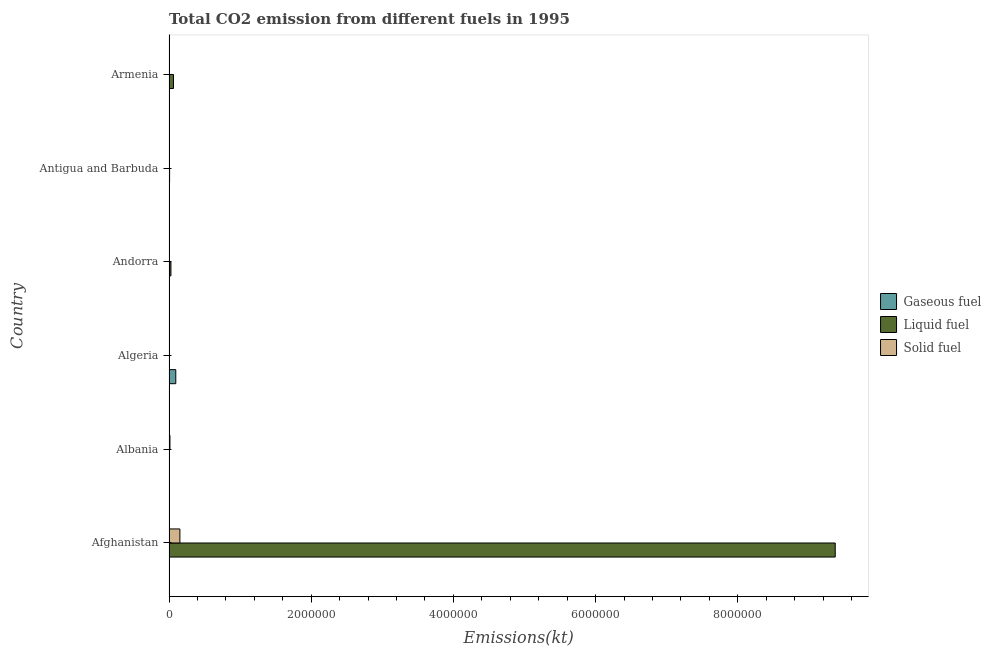How many different coloured bars are there?
Offer a very short reply. 3. How many groups of bars are there?
Ensure brevity in your answer.  6. Are the number of bars on each tick of the Y-axis equal?
Your response must be concise. Yes. How many bars are there on the 5th tick from the top?
Offer a very short reply. 3. How many bars are there on the 6th tick from the bottom?
Make the answer very short. 3. What is the label of the 3rd group of bars from the top?
Offer a terse response. Andorra. What is the amount of co2 emissions from solid fuel in Antigua and Barbuda?
Your answer should be very brief. 1221.11. Across all countries, what is the maximum amount of co2 emissions from liquid fuel?
Keep it short and to the point. 9.37e+06. Across all countries, what is the minimum amount of co2 emissions from solid fuel?
Keep it short and to the point. 3.67. In which country was the amount of co2 emissions from gaseous fuel maximum?
Make the answer very short. Algeria. In which country was the amount of co2 emissions from liquid fuel minimum?
Ensure brevity in your answer.  Albania. What is the total amount of co2 emissions from solid fuel in the graph?
Give a very brief answer. 1.73e+05. What is the difference between the amount of co2 emissions from liquid fuel in Andorra and that in Armenia?
Ensure brevity in your answer.  -3.58e+04. What is the difference between the amount of co2 emissions from gaseous fuel in Andorra and the amount of co2 emissions from solid fuel in Algeria?
Offer a very short reply. 392.37. What is the average amount of co2 emissions from gaseous fuel per country?
Make the answer very short. 1.72e+04. What is the difference between the amount of co2 emissions from gaseous fuel and amount of co2 emissions from solid fuel in Algeria?
Ensure brevity in your answer.  9.53e+04. In how many countries, is the amount of co2 emissions from solid fuel greater than 1600000 kt?
Provide a short and direct response. 0. What is the ratio of the amount of co2 emissions from solid fuel in Andorra to that in Armenia?
Offer a very short reply. 0. Is the amount of co2 emissions from liquid fuel in Afghanistan less than that in Algeria?
Offer a very short reply. No. What is the difference between the highest and the second highest amount of co2 emissions from solid fuel?
Ensure brevity in your answer.  1.40e+05. What is the difference between the highest and the lowest amount of co2 emissions from liquid fuel?
Offer a very short reply. 9.37e+06. What does the 3rd bar from the top in Algeria represents?
Offer a very short reply. Gaseous fuel. What does the 1st bar from the bottom in Armenia represents?
Make the answer very short. Gaseous fuel. Is it the case that in every country, the sum of the amount of co2 emissions from gaseous fuel and amount of co2 emissions from liquid fuel is greater than the amount of co2 emissions from solid fuel?
Provide a succinct answer. No. How many bars are there?
Offer a terse response. 18. Are all the bars in the graph horizontal?
Your answer should be compact. Yes. Are the values on the major ticks of X-axis written in scientific E-notation?
Make the answer very short. No. Does the graph contain any zero values?
Offer a very short reply. No. Does the graph contain grids?
Offer a very short reply. No. How many legend labels are there?
Provide a succinct answer. 3. What is the title of the graph?
Ensure brevity in your answer.  Total CO2 emission from different fuels in 1995. What is the label or title of the X-axis?
Provide a short and direct response. Emissions(kt). What is the Emissions(kt) in Gaseous fuel in Afghanistan?
Your answer should be very brief. 1268.78. What is the Emissions(kt) in Liquid fuel in Afghanistan?
Your answer should be compact. 9.37e+06. What is the Emissions(kt) in Solid fuel in Afghanistan?
Your response must be concise. 1.53e+05. What is the Emissions(kt) of Gaseous fuel in Albania?
Provide a succinct answer. 2086.52. What is the Emissions(kt) of Liquid fuel in Albania?
Your answer should be compact. 850.74. What is the Emissions(kt) in Solid fuel in Albania?
Offer a terse response. 1.32e+04. What is the Emissions(kt) in Gaseous fuel in Algeria?
Offer a very short reply. 9.53e+04. What is the Emissions(kt) in Liquid fuel in Algeria?
Your answer should be very brief. 1774.83. What is the Emissions(kt) in Solid fuel in Algeria?
Your answer should be compact. 14.67. What is the Emissions(kt) of Gaseous fuel in Andorra?
Your answer should be compact. 407.04. What is the Emissions(kt) of Liquid fuel in Andorra?
Provide a short and direct response. 2.71e+04. What is the Emissions(kt) in Solid fuel in Andorra?
Your answer should be very brief. 3.67. What is the Emissions(kt) of Gaseous fuel in Antigua and Barbuda?
Keep it short and to the point. 322.7. What is the Emissions(kt) of Liquid fuel in Antigua and Barbuda?
Make the answer very short. 8459.77. What is the Emissions(kt) in Solid fuel in Antigua and Barbuda?
Your response must be concise. 1221.11. What is the Emissions(kt) of Gaseous fuel in Armenia?
Ensure brevity in your answer.  3490.98. What is the Emissions(kt) of Liquid fuel in Armenia?
Give a very brief answer. 6.29e+04. What is the Emissions(kt) of Solid fuel in Armenia?
Keep it short and to the point. 5291.48. Across all countries, what is the maximum Emissions(kt) in Gaseous fuel?
Your answer should be very brief. 9.53e+04. Across all countries, what is the maximum Emissions(kt) of Liquid fuel?
Your answer should be very brief. 9.37e+06. Across all countries, what is the maximum Emissions(kt) of Solid fuel?
Keep it short and to the point. 1.53e+05. Across all countries, what is the minimum Emissions(kt) of Gaseous fuel?
Give a very brief answer. 322.7. Across all countries, what is the minimum Emissions(kt) in Liquid fuel?
Provide a succinct answer. 850.74. Across all countries, what is the minimum Emissions(kt) of Solid fuel?
Your response must be concise. 3.67. What is the total Emissions(kt) in Gaseous fuel in the graph?
Keep it short and to the point. 1.03e+05. What is the total Emissions(kt) in Liquid fuel in the graph?
Keep it short and to the point. 9.47e+06. What is the total Emissions(kt) of Solid fuel in the graph?
Make the answer very short. 1.73e+05. What is the difference between the Emissions(kt) in Gaseous fuel in Afghanistan and that in Albania?
Offer a terse response. -817.74. What is the difference between the Emissions(kt) in Liquid fuel in Afghanistan and that in Albania?
Provide a succinct answer. 9.37e+06. What is the difference between the Emissions(kt) of Solid fuel in Afghanistan and that in Albania?
Offer a very short reply. 1.40e+05. What is the difference between the Emissions(kt) of Gaseous fuel in Afghanistan and that in Algeria?
Ensure brevity in your answer.  -9.41e+04. What is the difference between the Emissions(kt) in Liquid fuel in Afghanistan and that in Algeria?
Give a very brief answer. 9.37e+06. What is the difference between the Emissions(kt) of Solid fuel in Afghanistan and that in Algeria?
Your answer should be compact. 1.53e+05. What is the difference between the Emissions(kt) of Gaseous fuel in Afghanistan and that in Andorra?
Provide a succinct answer. 861.75. What is the difference between the Emissions(kt) of Liquid fuel in Afghanistan and that in Andorra?
Make the answer very short. 9.34e+06. What is the difference between the Emissions(kt) in Solid fuel in Afghanistan and that in Andorra?
Give a very brief answer. 1.53e+05. What is the difference between the Emissions(kt) in Gaseous fuel in Afghanistan and that in Antigua and Barbuda?
Give a very brief answer. 946.09. What is the difference between the Emissions(kt) in Liquid fuel in Afghanistan and that in Antigua and Barbuda?
Your answer should be very brief. 9.36e+06. What is the difference between the Emissions(kt) in Solid fuel in Afghanistan and that in Antigua and Barbuda?
Keep it short and to the point. 1.52e+05. What is the difference between the Emissions(kt) of Gaseous fuel in Afghanistan and that in Armenia?
Offer a very short reply. -2222.2. What is the difference between the Emissions(kt) in Liquid fuel in Afghanistan and that in Armenia?
Keep it short and to the point. 9.31e+06. What is the difference between the Emissions(kt) of Solid fuel in Afghanistan and that in Armenia?
Keep it short and to the point. 1.48e+05. What is the difference between the Emissions(kt) of Gaseous fuel in Albania and that in Algeria?
Your answer should be very brief. -9.33e+04. What is the difference between the Emissions(kt) in Liquid fuel in Albania and that in Algeria?
Provide a short and direct response. -924.08. What is the difference between the Emissions(kt) in Solid fuel in Albania and that in Algeria?
Ensure brevity in your answer.  1.32e+04. What is the difference between the Emissions(kt) of Gaseous fuel in Albania and that in Andorra?
Your answer should be compact. 1679.49. What is the difference between the Emissions(kt) of Liquid fuel in Albania and that in Andorra?
Offer a terse response. -2.63e+04. What is the difference between the Emissions(kt) of Solid fuel in Albania and that in Andorra?
Your response must be concise. 1.32e+04. What is the difference between the Emissions(kt) in Gaseous fuel in Albania and that in Antigua and Barbuda?
Give a very brief answer. 1763.83. What is the difference between the Emissions(kt) of Liquid fuel in Albania and that in Antigua and Barbuda?
Your answer should be compact. -7609.02. What is the difference between the Emissions(kt) in Solid fuel in Albania and that in Antigua and Barbuda?
Your answer should be very brief. 1.20e+04. What is the difference between the Emissions(kt) in Gaseous fuel in Albania and that in Armenia?
Your response must be concise. -1404.46. What is the difference between the Emissions(kt) of Liquid fuel in Albania and that in Armenia?
Provide a short and direct response. -6.20e+04. What is the difference between the Emissions(kt) of Solid fuel in Albania and that in Armenia?
Your answer should be very brief. 7924.39. What is the difference between the Emissions(kt) of Gaseous fuel in Algeria and that in Andorra?
Your response must be concise. 9.49e+04. What is the difference between the Emissions(kt) in Liquid fuel in Algeria and that in Andorra?
Your response must be concise. -2.53e+04. What is the difference between the Emissions(kt) in Solid fuel in Algeria and that in Andorra?
Provide a short and direct response. 11. What is the difference between the Emissions(kt) of Gaseous fuel in Algeria and that in Antigua and Barbuda?
Offer a terse response. 9.50e+04. What is the difference between the Emissions(kt) in Liquid fuel in Algeria and that in Antigua and Barbuda?
Give a very brief answer. -6684.94. What is the difference between the Emissions(kt) of Solid fuel in Algeria and that in Antigua and Barbuda?
Your response must be concise. -1206.44. What is the difference between the Emissions(kt) of Gaseous fuel in Algeria and that in Armenia?
Offer a very short reply. 9.19e+04. What is the difference between the Emissions(kt) in Liquid fuel in Algeria and that in Armenia?
Ensure brevity in your answer.  -6.11e+04. What is the difference between the Emissions(kt) of Solid fuel in Algeria and that in Armenia?
Provide a succinct answer. -5276.81. What is the difference between the Emissions(kt) in Gaseous fuel in Andorra and that in Antigua and Barbuda?
Give a very brief answer. 84.34. What is the difference between the Emissions(kt) in Liquid fuel in Andorra and that in Antigua and Barbuda?
Provide a short and direct response. 1.86e+04. What is the difference between the Emissions(kt) of Solid fuel in Andorra and that in Antigua and Barbuda?
Provide a succinct answer. -1217.44. What is the difference between the Emissions(kt) of Gaseous fuel in Andorra and that in Armenia?
Provide a succinct answer. -3083.95. What is the difference between the Emissions(kt) of Liquid fuel in Andorra and that in Armenia?
Offer a very short reply. -3.58e+04. What is the difference between the Emissions(kt) in Solid fuel in Andorra and that in Armenia?
Give a very brief answer. -5287.81. What is the difference between the Emissions(kt) in Gaseous fuel in Antigua and Barbuda and that in Armenia?
Make the answer very short. -3168.29. What is the difference between the Emissions(kt) in Liquid fuel in Antigua and Barbuda and that in Armenia?
Offer a very short reply. -5.44e+04. What is the difference between the Emissions(kt) of Solid fuel in Antigua and Barbuda and that in Armenia?
Provide a succinct answer. -4070.37. What is the difference between the Emissions(kt) in Gaseous fuel in Afghanistan and the Emissions(kt) in Liquid fuel in Albania?
Offer a terse response. 418.04. What is the difference between the Emissions(kt) of Gaseous fuel in Afghanistan and the Emissions(kt) of Solid fuel in Albania?
Your answer should be very brief. -1.19e+04. What is the difference between the Emissions(kt) in Liquid fuel in Afghanistan and the Emissions(kt) in Solid fuel in Albania?
Provide a succinct answer. 9.36e+06. What is the difference between the Emissions(kt) of Gaseous fuel in Afghanistan and the Emissions(kt) of Liquid fuel in Algeria?
Offer a terse response. -506.05. What is the difference between the Emissions(kt) in Gaseous fuel in Afghanistan and the Emissions(kt) in Solid fuel in Algeria?
Provide a short and direct response. 1254.11. What is the difference between the Emissions(kt) in Liquid fuel in Afghanistan and the Emissions(kt) in Solid fuel in Algeria?
Your response must be concise. 9.37e+06. What is the difference between the Emissions(kt) of Gaseous fuel in Afghanistan and the Emissions(kt) of Liquid fuel in Andorra?
Offer a terse response. -2.58e+04. What is the difference between the Emissions(kt) of Gaseous fuel in Afghanistan and the Emissions(kt) of Solid fuel in Andorra?
Ensure brevity in your answer.  1265.12. What is the difference between the Emissions(kt) of Liquid fuel in Afghanistan and the Emissions(kt) of Solid fuel in Andorra?
Your answer should be compact. 9.37e+06. What is the difference between the Emissions(kt) in Gaseous fuel in Afghanistan and the Emissions(kt) in Liquid fuel in Antigua and Barbuda?
Provide a short and direct response. -7190.99. What is the difference between the Emissions(kt) of Gaseous fuel in Afghanistan and the Emissions(kt) of Solid fuel in Antigua and Barbuda?
Ensure brevity in your answer.  47.67. What is the difference between the Emissions(kt) of Liquid fuel in Afghanistan and the Emissions(kt) of Solid fuel in Antigua and Barbuda?
Make the answer very short. 9.37e+06. What is the difference between the Emissions(kt) in Gaseous fuel in Afghanistan and the Emissions(kt) in Liquid fuel in Armenia?
Your answer should be compact. -6.16e+04. What is the difference between the Emissions(kt) of Gaseous fuel in Afghanistan and the Emissions(kt) of Solid fuel in Armenia?
Your answer should be compact. -4022.7. What is the difference between the Emissions(kt) in Liquid fuel in Afghanistan and the Emissions(kt) in Solid fuel in Armenia?
Give a very brief answer. 9.37e+06. What is the difference between the Emissions(kt) of Gaseous fuel in Albania and the Emissions(kt) of Liquid fuel in Algeria?
Provide a succinct answer. 311.69. What is the difference between the Emissions(kt) of Gaseous fuel in Albania and the Emissions(kt) of Solid fuel in Algeria?
Keep it short and to the point. 2071.86. What is the difference between the Emissions(kt) of Liquid fuel in Albania and the Emissions(kt) of Solid fuel in Algeria?
Provide a short and direct response. 836.08. What is the difference between the Emissions(kt) in Gaseous fuel in Albania and the Emissions(kt) in Liquid fuel in Andorra?
Offer a very short reply. -2.50e+04. What is the difference between the Emissions(kt) of Gaseous fuel in Albania and the Emissions(kt) of Solid fuel in Andorra?
Make the answer very short. 2082.86. What is the difference between the Emissions(kt) in Liquid fuel in Albania and the Emissions(kt) in Solid fuel in Andorra?
Offer a terse response. 847.08. What is the difference between the Emissions(kt) in Gaseous fuel in Albania and the Emissions(kt) in Liquid fuel in Antigua and Barbuda?
Your response must be concise. -6373.25. What is the difference between the Emissions(kt) of Gaseous fuel in Albania and the Emissions(kt) of Solid fuel in Antigua and Barbuda?
Offer a terse response. 865.41. What is the difference between the Emissions(kt) of Liquid fuel in Albania and the Emissions(kt) of Solid fuel in Antigua and Barbuda?
Offer a terse response. -370.37. What is the difference between the Emissions(kt) of Gaseous fuel in Albania and the Emissions(kt) of Liquid fuel in Armenia?
Give a very brief answer. -6.08e+04. What is the difference between the Emissions(kt) in Gaseous fuel in Albania and the Emissions(kt) in Solid fuel in Armenia?
Your response must be concise. -3204.96. What is the difference between the Emissions(kt) in Liquid fuel in Albania and the Emissions(kt) in Solid fuel in Armenia?
Your response must be concise. -4440.74. What is the difference between the Emissions(kt) of Gaseous fuel in Algeria and the Emissions(kt) of Liquid fuel in Andorra?
Give a very brief answer. 6.82e+04. What is the difference between the Emissions(kt) in Gaseous fuel in Algeria and the Emissions(kt) in Solid fuel in Andorra?
Provide a short and direct response. 9.53e+04. What is the difference between the Emissions(kt) of Liquid fuel in Algeria and the Emissions(kt) of Solid fuel in Andorra?
Provide a succinct answer. 1771.16. What is the difference between the Emissions(kt) of Gaseous fuel in Algeria and the Emissions(kt) of Liquid fuel in Antigua and Barbuda?
Give a very brief answer. 8.69e+04. What is the difference between the Emissions(kt) in Gaseous fuel in Algeria and the Emissions(kt) in Solid fuel in Antigua and Barbuda?
Give a very brief answer. 9.41e+04. What is the difference between the Emissions(kt) of Liquid fuel in Algeria and the Emissions(kt) of Solid fuel in Antigua and Barbuda?
Provide a succinct answer. 553.72. What is the difference between the Emissions(kt) in Gaseous fuel in Algeria and the Emissions(kt) in Liquid fuel in Armenia?
Provide a short and direct response. 3.25e+04. What is the difference between the Emissions(kt) of Gaseous fuel in Algeria and the Emissions(kt) of Solid fuel in Armenia?
Keep it short and to the point. 9.01e+04. What is the difference between the Emissions(kt) of Liquid fuel in Algeria and the Emissions(kt) of Solid fuel in Armenia?
Give a very brief answer. -3516.65. What is the difference between the Emissions(kt) in Gaseous fuel in Andorra and the Emissions(kt) in Liquid fuel in Antigua and Barbuda?
Give a very brief answer. -8052.73. What is the difference between the Emissions(kt) in Gaseous fuel in Andorra and the Emissions(kt) in Solid fuel in Antigua and Barbuda?
Give a very brief answer. -814.07. What is the difference between the Emissions(kt) in Liquid fuel in Andorra and the Emissions(kt) in Solid fuel in Antigua and Barbuda?
Keep it short and to the point. 2.59e+04. What is the difference between the Emissions(kt) of Gaseous fuel in Andorra and the Emissions(kt) of Liquid fuel in Armenia?
Provide a succinct answer. -6.25e+04. What is the difference between the Emissions(kt) in Gaseous fuel in Andorra and the Emissions(kt) in Solid fuel in Armenia?
Your answer should be very brief. -4884.44. What is the difference between the Emissions(kt) of Liquid fuel in Andorra and the Emissions(kt) of Solid fuel in Armenia?
Offer a terse response. 2.18e+04. What is the difference between the Emissions(kt) in Gaseous fuel in Antigua and Barbuda and the Emissions(kt) in Liquid fuel in Armenia?
Offer a terse response. -6.26e+04. What is the difference between the Emissions(kt) of Gaseous fuel in Antigua and Barbuda and the Emissions(kt) of Solid fuel in Armenia?
Keep it short and to the point. -4968.78. What is the difference between the Emissions(kt) in Liquid fuel in Antigua and Barbuda and the Emissions(kt) in Solid fuel in Armenia?
Offer a very short reply. 3168.29. What is the average Emissions(kt) of Gaseous fuel per country?
Ensure brevity in your answer.  1.72e+04. What is the average Emissions(kt) in Liquid fuel per country?
Your answer should be compact. 1.58e+06. What is the average Emissions(kt) of Solid fuel per country?
Provide a short and direct response. 2.88e+04. What is the difference between the Emissions(kt) of Gaseous fuel and Emissions(kt) of Liquid fuel in Afghanistan?
Provide a succinct answer. -9.37e+06. What is the difference between the Emissions(kt) in Gaseous fuel and Emissions(kt) in Solid fuel in Afghanistan?
Your answer should be very brief. -1.52e+05. What is the difference between the Emissions(kt) of Liquid fuel and Emissions(kt) of Solid fuel in Afghanistan?
Your answer should be compact. 9.22e+06. What is the difference between the Emissions(kt) in Gaseous fuel and Emissions(kt) in Liquid fuel in Albania?
Ensure brevity in your answer.  1235.78. What is the difference between the Emissions(kt) in Gaseous fuel and Emissions(kt) in Solid fuel in Albania?
Offer a terse response. -1.11e+04. What is the difference between the Emissions(kt) of Liquid fuel and Emissions(kt) of Solid fuel in Albania?
Provide a succinct answer. -1.24e+04. What is the difference between the Emissions(kt) of Gaseous fuel and Emissions(kt) of Liquid fuel in Algeria?
Your response must be concise. 9.36e+04. What is the difference between the Emissions(kt) of Gaseous fuel and Emissions(kt) of Solid fuel in Algeria?
Make the answer very short. 9.53e+04. What is the difference between the Emissions(kt) in Liquid fuel and Emissions(kt) in Solid fuel in Algeria?
Make the answer very short. 1760.16. What is the difference between the Emissions(kt) of Gaseous fuel and Emissions(kt) of Liquid fuel in Andorra?
Make the answer very short. -2.67e+04. What is the difference between the Emissions(kt) of Gaseous fuel and Emissions(kt) of Solid fuel in Andorra?
Offer a terse response. 403.37. What is the difference between the Emissions(kt) of Liquid fuel and Emissions(kt) of Solid fuel in Andorra?
Give a very brief answer. 2.71e+04. What is the difference between the Emissions(kt) in Gaseous fuel and Emissions(kt) in Liquid fuel in Antigua and Barbuda?
Your answer should be very brief. -8137.07. What is the difference between the Emissions(kt) of Gaseous fuel and Emissions(kt) of Solid fuel in Antigua and Barbuda?
Your response must be concise. -898.41. What is the difference between the Emissions(kt) of Liquid fuel and Emissions(kt) of Solid fuel in Antigua and Barbuda?
Your response must be concise. 7238.66. What is the difference between the Emissions(kt) of Gaseous fuel and Emissions(kt) of Liquid fuel in Armenia?
Give a very brief answer. -5.94e+04. What is the difference between the Emissions(kt) of Gaseous fuel and Emissions(kt) of Solid fuel in Armenia?
Give a very brief answer. -1800.5. What is the difference between the Emissions(kt) in Liquid fuel and Emissions(kt) in Solid fuel in Armenia?
Make the answer very short. 5.76e+04. What is the ratio of the Emissions(kt) of Gaseous fuel in Afghanistan to that in Albania?
Provide a succinct answer. 0.61. What is the ratio of the Emissions(kt) in Liquid fuel in Afghanistan to that in Albania?
Give a very brief answer. 1.10e+04. What is the ratio of the Emissions(kt) in Solid fuel in Afghanistan to that in Albania?
Provide a succinct answer. 11.6. What is the ratio of the Emissions(kt) in Gaseous fuel in Afghanistan to that in Algeria?
Make the answer very short. 0.01. What is the ratio of the Emissions(kt) in Liquid fuel in Afghanistan to that in Algeria?
Offer a very short reply. 5279.6. What is the ratio of the Emissions(kt) in Solid fuel in Afghanistan to that in Algeria?
Make the answer very short. 1.04e+04. What is the ratio of the Emissions(kt) of Gaseous fuel in Afghanistan to that in Andorra?
Offer a very short reply. 3.12. What is the ratio of the Emissions(kt) of Liquid fuel in Afghanistan to that in Andorra?
Provide a succinct answer. 345.73. What is the ratio of the Emissions(kt) in Solid fuel in Afghanistan to that in Andorra?
Give a very brief answer. 4.18e+04. What is the ratio of the Emissions(kt) of Gaseous fuel in Afghanistan to that in Antigua and Barbuda?
Your answer should be very brief. 3.93. What is the ratio of the Emissions(kt) in Liquid fuel in Afghanistan to that in Antigua and Barbuda?
Your response must be concise. 1107.64. What is the ratio of the Emissions(kt) in Solid fuel in Afghanistan to that in Antigua and Barbuda?
Keep it short and to the point. 125.52. What is the ratio of the Emissions(kt) in Gaseous fuel in Afghanistan to that in Armenia?
Make the answer very short. 0.36. What is the ratio of the Emissions(kt) in Liquid fuel in Afghanistan to that in Armenia?
Provide a succinct answer. 149.01. What is the ratio of the Emissions(kt) in Solid fuel in Afghanistan to that in Armenia?
Offer a terse response. 28.97. What is the ratio of the Emissions(kt) of Gaseous fuel in Albania to that in Algeria?
Offer a very short reply. 0.02. What is the ratio of the Emissions(kt) in Liquid fuel in Albania to that in Algeria?
Provide a short and direct response. 0.48. What is the ratio of the Emissions(kt) in Solid fuel in Albania to that in Algeria?
Your answer should be very brief. 901. What is the ratio of the Emissions(kt) of Gaseous fuel in Albania to that in Andorra?
Your response must be concise. 5.13. What is the ratio of the Emissions(kt) in Liquid fuel in Albania to that in Andorra?
Give a very brief answer. 0.03. What is the ratio of the Emissions(kt) of Solid fuel in Albania to that in Andorra?
Provide a short and direct response. 3604. What is the ratio of the Emissions(kt) in Gaseous fuel in Albania to that in Antigua and Barbuda?
Provide a succinct answer. 6.47. What is the ratio of the Emissions(kt) of Liquid fuel in Albania to that in Antigua and Barbuda?
Ensure brevity in your answer.  0.1. What is the ratio of the Emissions(kt) of Solid fuel in Albania to that in Antigua and Barbuda?
Ensure brevity in your answer.  10.82. What is the ratio of the Emissions(kt) in Gaseous fuel in Albania to that in Armenia?
Your answer should be very brief. 0.6. What is the ratio of the Emissions(kt) in Liquid fuel in Albania to that in Armenia?
Offer a terse response. 0.01. What is the ratio of the Emissions(kt) of Solid fuel in Albania to that in Armenia?
Your answer should be compact. 2.5. What is the ratio of the Emissions(kt) of Gaseous fuel in Algeria to that in Andorra?
Keep it short and to the point. 234.24. What is the ratio of the Emissions(kt) of Liquid fuel in Algeria to that in Andorra?
Provide a short and direct response. 0.07. What is the ratio of the Emissions(kt) of Gaseous fuel in Algeria to that in Antigua and Barbuda?
Give a very brief answer. 295.47. What is the ratio of the Emissions(kt) in Liquid fuel in Algeria to that in Antigua and Barbuda?
Give a very brief answer. 0.21. What is the ratio of the Emissions(kt) in Solid fuel in Algeria to that in Antigua and Barbuda?
Ensure brevity in your answer.  0.01. What is the ratio of the Emissions(kt) in Gaseous fuel in Algeria to that in Armenia?
Your answer should be compact. 27.31. What is the ratio of the Emissions(kt) in Liquid fuel in Algeria to that in Armenia?
Provide a succinct answer. 0.03. What is the ratio of the Emissions(kt) in Solid fuel in Algeria to that in Armenia?
Your response must be concise. 0. What is the ratio of the Emissions(kt) in Gaseous fuel in Andorra to that in Antigua and Barbuda?
Your response must be concise. 1.26. What is the ratio of the Emissions(kt) of Liquid fuel in Andorra to that in Antigua and Barbuda?
Make the answer very short. 3.2. What is the ratio of the Emissions(kt) in Solid fuel in Andorra to that in Antigua and Barbuda?
Ensure brevity in your answer.  0. What is the ratio of the Emissions(kt) of Gaseous fuel in Andorra to that in Armenia?
Your response must be concise. 0.12. What is the ratio of the Emissions(kt) in Liquid fuel in Andorra to that in Armenia?
Give a very brief answer. 0.43. What is the ratio of the Emissions(kt) of Solid fuel in Andorra to that in Armenia?
Provide a succinct answer. 0. What is the ratio of the Emissions(kt) of Gaseous fuel in Antigua and Barbuda to that in Armenia?
Your answer should be very brief. 0.09. What is the ratio of the Emissions(kt) in Liquid fuel in Antigua and Barbuda to that in Armenia?
Provide a short and direct response. 0.13. What is the ratio of the Emissions(kt) in Solid fuel in Antigua and Barbuda to that in Armenia?
Ensure brevity in your answer.  0.23. What is the difference between the highest and the second highest Emissions(kt) of Gaseous fuel?
Keep it short and to the point. 9.19e+04. What is the difference between the highest and the second highest Emissions(kt) in Liquid fuel?
Provide a short and direct response. 9.31e+06. What is the difference between the highest and the second highest Emissions(kt) in Solid fuel?
Your answer should be very brief. 1.40e+05. What is the difference between the highest and the lowest Emissions(kt) in Gaseous fuel?
Your response must be concise. 9.50e+04. What is the difference between the highest and the lowest Emissions(kt) of Liquid fuel?
Provide a short and direct response. 9.37e+06. What is the difference between the highest and the lowest Emissions(kt) in Solid fuel?
Ensure brevity in your answer.  1.53e+05. 